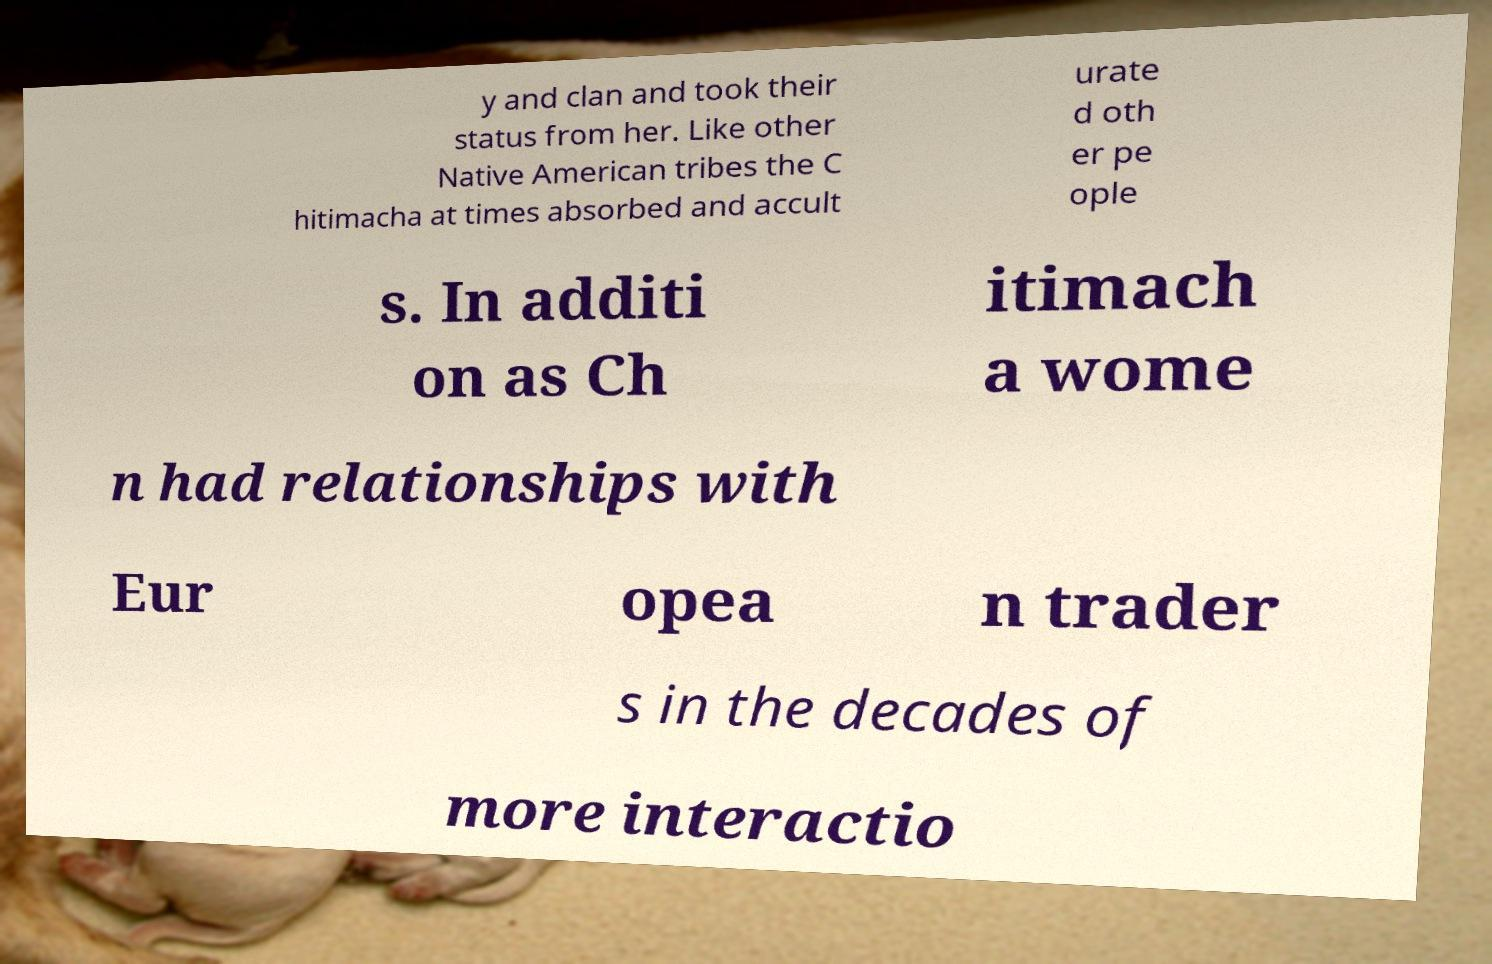What messages or text are displayed in this image? I need them in a readable, typed format. y and clan and took their status from her. Like other Native American tribes the C hitimacha at times absorbed and accult urate d oth er pe ople s. In additi on as Ch itimach a wome n had relationships with Eur opea n trader s in the decades of more interactio 